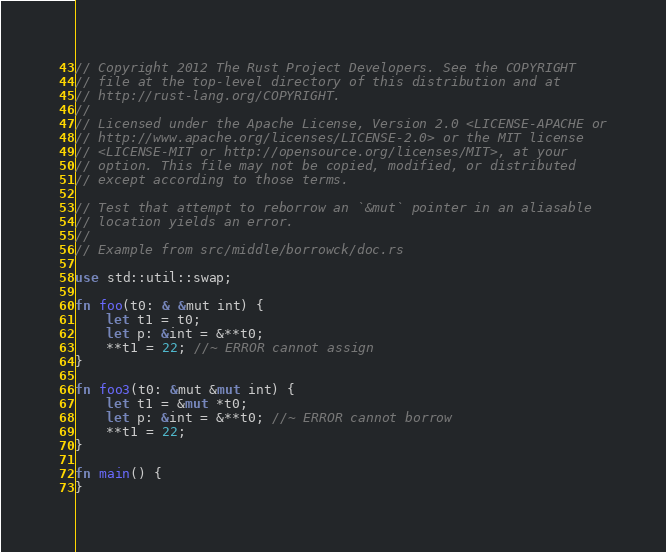<code> <loc_0><loc_0><loc_500><loc_500><_Rust_>// Copyright 2012 The Rust Project Developers. See the COPYRIGHT
// file at the top-level directory of this distribution and at
// http://rust-lang.org/COPYRIGHT.
//
// Licensed under the Apache License, Version 2.0 <LICENSE-APACHE or
// http://www.apache.org/licenses/LICENSE-2.0> or the MIT license
// <LICENSE-MIT or http://opensource.org/licenses/MIT>, at your
// option. This file may not be copied, modified, or distributed
// except according to those terms.

// Test that attempt to reborrow an `&mut` pointer in an aliasable
// location yields an error.
//
// Example from src/middle/borrowck/doc.rs

use std::util::swap;

fn foo(t0: & &mut int) {
    let t1 = t0;
    let p: &int = &**t0;
    **t1 = 22; //~ ERROR cannot assign
}

fn foo3(t0: &mut &mut int) {
    let t1 = &mut *t0;
    let p: &int = &**t0; //~ ERROR cannot borrow
    **t1 = 22;
}

fn main() {
}
</code> 